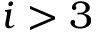<formula> <loc_0><loc_0><loc_500><loc_500>i > 3</formula> 